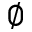<formula> <loc_0><loc_0><loc_500><loc_500>\emptyset</formula> 